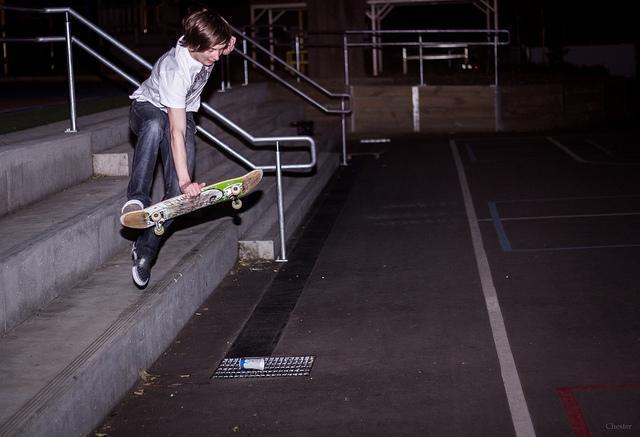How many cows are in the photo?
Give a very brief answer. 0. 